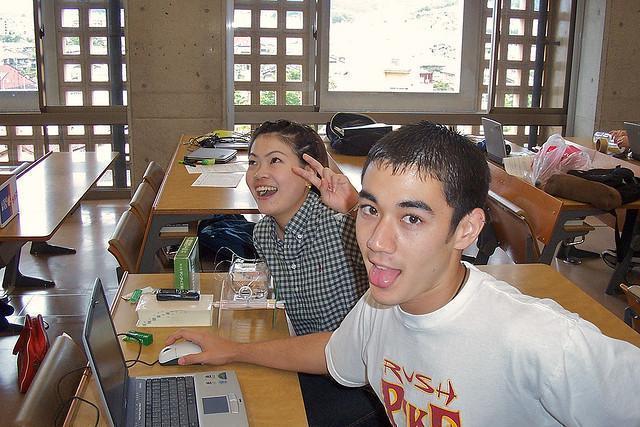Where are these young people seated?
Select the accurate answer and provide justification: `Answer: choice
Rationale: srationale.`
Options: Library, church, airport, school. Answer: school.
Rationale: The young people are in school. 